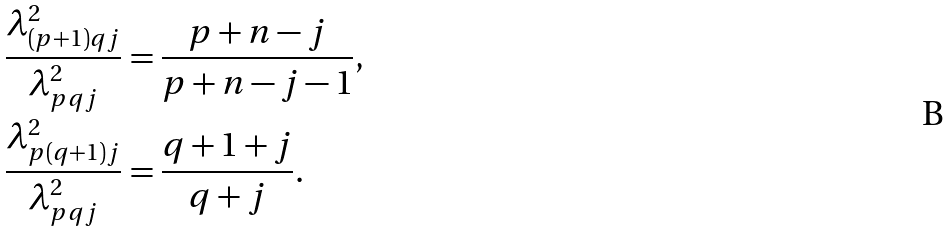Convert formula to latex. <formula><loc_0><loc_0><loc_500><loc_500>\frac { \lambda _ { ( p + 1 ) q j } ^ { 2 } } { \lambda _ { p q j } ^ { 2 } } & = \frac { p + n - j } { p + n - j - 1 } , \\ \frac { \lambda _ { p ( q + 1 ) j } ^ { 2 } } { \lambda _ { p q j } ^ { 2 } } & = \frac { q + 1 + j } { q + j } .</formula> 